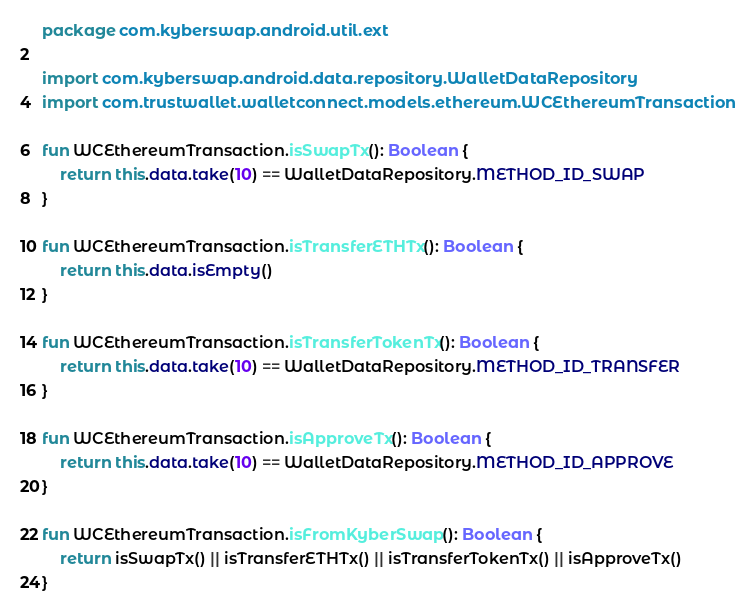<code> <loc_0><loc_0><loc_500><loc_500><_Kotlin_>package com.kyberswap.android.util.ext

import com.kyberswap.android.data.repository.WalletDataRepository
import com.trustwallet.walletconnect.models.ethereum.WCEthereumTransaction

fun WCEthereumTransaction.isSwapTx(): Boolean {
    return this.data.take(10) == WalletDataRepository.METHOD_ID_SWAP
}

fun WCEthereumTransaction.isTransferETHTx(): Boolean {
    return this.data.isEmpty()
}

fun WCEthereumTransaction.isTransferTokenTx(): Boolean {
    return this.data.take(10) == WalletDataRepository.METHOD_ID_TRANSFER
}

fun WCEthereumTransaction.isApproveTx(): Boolean {
    return this.data.take(10) == WalletDataRepository.METHOD_ID_APPROVE
}

fun WCEthereumTransaction.isFromKyberSwap(): Boolean {
    return isSwapTx() || isTransferETHTx() || isTransferTokenTx() || isApproveTx()
}</code> 